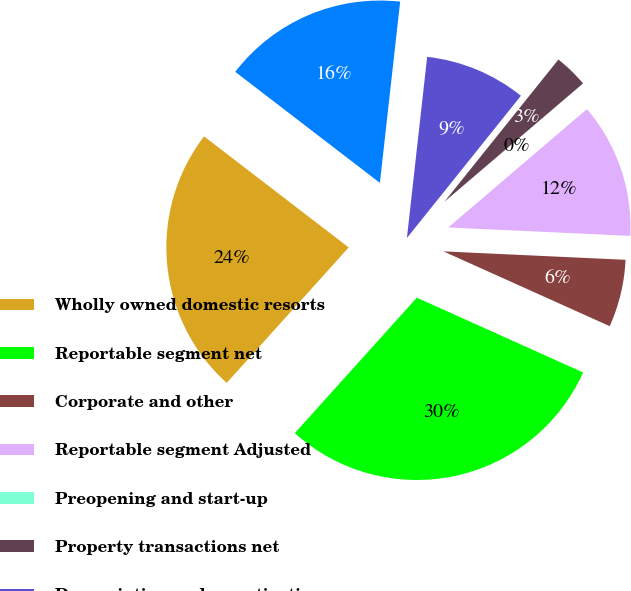<chart> <loc_0><loc_0><loc_500><loc_500><pie_chart><fcel>Wholly owned domestic resorts<fcel>Reportable segment net<fcel>Corporate and other<fcel>Reportable segment Adjusted<fcel>Preopening and start-up<fcel>Property transactions net<fcel>Depreciation and amortization<fcel>Operating income (loss)<nl><fcel>23.75%<fcel>29.94%<fcel>5.99%<fcel>11.98%<fcel>0.0%<fcel>3.0%<fcel>8.98%<fcel>16.35%<nl></chart> 